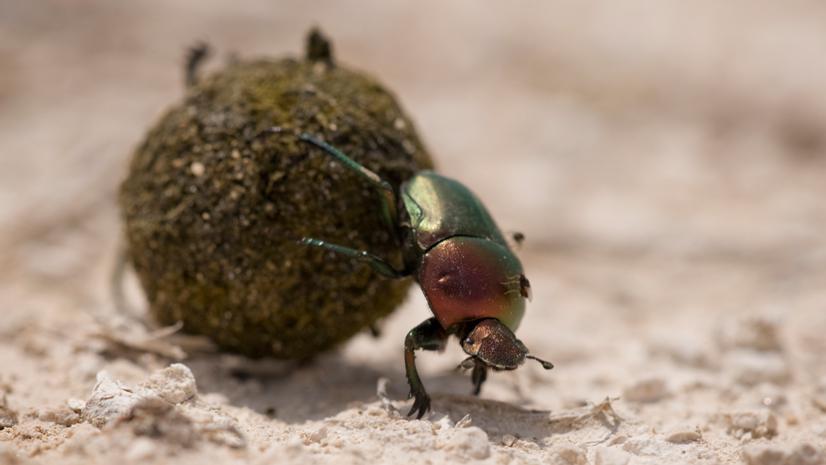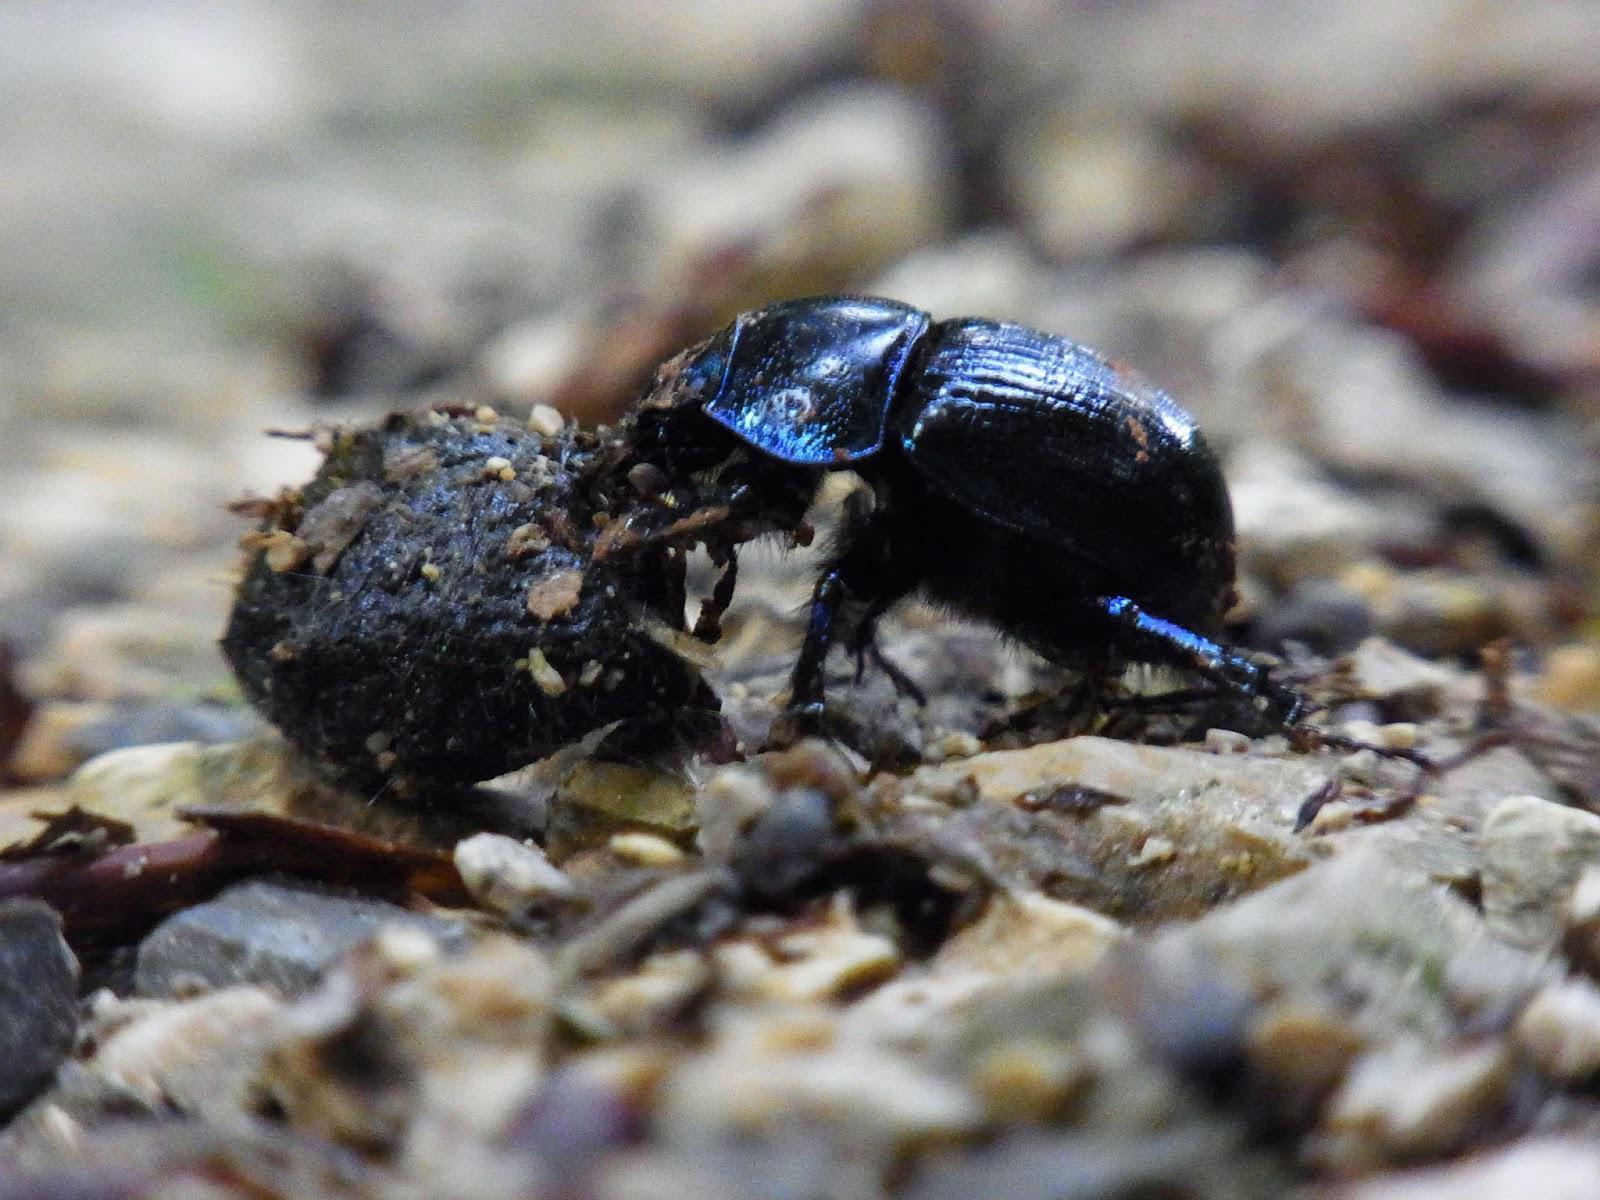The first image is the image on the left, the second image is the image on the right. Examine the images to the left and right. Is the description "There are exactly three dung beetles." accurate? Answer yes or no. No. The first image is the image on the left, the second image is the image on the right. Examine the images to the left and right. Is the description "there is one beetle with dung in the left side image" accurate? Answer yes or no. Yes. 